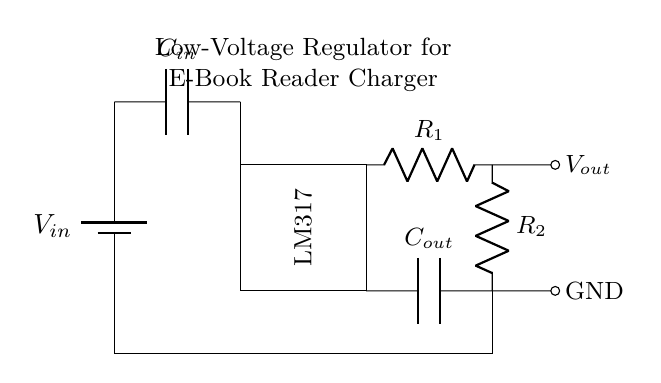What type of regulator is shown in the circuit? The circuit includes an LM317, which is a type of linear voltage regulator commonly used for providing variable output voltages.
Answer: LM317 What do the capacitors in the circuit do? The input capacitor stores energy to smooth out the input voltage fluctuations, while the output capacitor helps stabilize the output voltage and reduce noise.
Answer: Stabilizing What is the role of R1 and R2 in the circuit? Resistors R1 and R2 are used to set the output voltage level of the regulator by forming a voltage divider, allowing the LM317 to provide the desired output voltage.
Answer: Voltage divider What is the voltage source marked as V_in? V_in represents the input voltage supplied to the regulator, typically coming from an external source like a battery.
Answer: Input voltage Why is there a ground connection in the circuit? The ground connection ensures a common reference point for all voltages in the circuit, which is essential for proper operation and stability of the voltage regulator.
Answer: Common reference What does C_out indicate in this circuit? C_out is the output capacitor that improves output stability and reduces voltage ripple, ensuring a smoother power supply to the e-book reader.
Answer: Output stability 